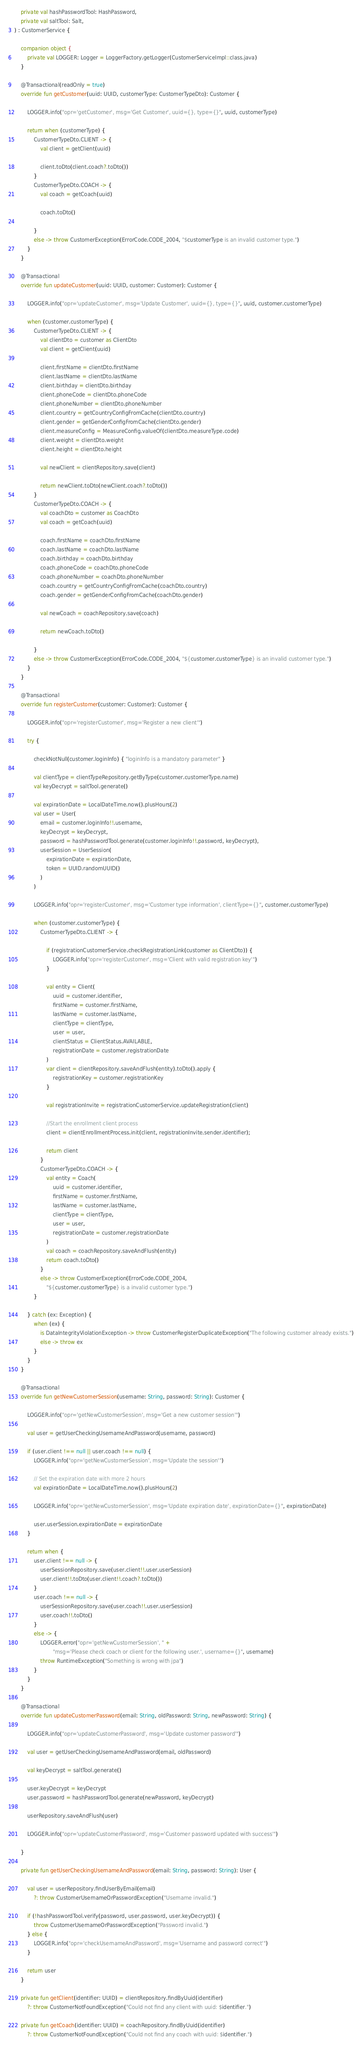Convert code to text. <code><loc_0><loc_0><loc_500><loc_500><_Kotlin_>    private val hashPasswordTool: HashPassword,
    private val saltTool: Salt,
) : CustomerService {

    companion object {
        private val LOGGER: Logger = LoggerFactory.getLogger(CustomerServiceImpl::class.java)
    }

    @Transactional(readOnly = true)
    override fun getCustomer(uuid: UUID, customerType: CustomerTypeDto): Customer {

        LOGGER.info("opr='getCustomer', msg='Get Customer', uuid={}, type={}", uuid, customerType)

        return when (customerType) {
            CustomerTypeDto.CLIENT -> {
                val client = getClient(uuid)

                client.toDto(client.coach?.toDto())
            }
            CustomerTypeDto.COACH -> {
                val coach = getCoach(uuid)

                coach.toDto()

            }
            else -> throw CustomerException(ErrorCode.CODE_2004, "$customerType is an invalid customer type.")
        }
    }

    @Transactional
    override fun updateCustomer(uuid: UUID, customer: Customer): Customer {

        LOGGER.info("opr='updateCustomer', msg='Update Customer', uuid={}, type={}", uuid, customer.customerType)

        when (customer.customerType) {
            CustomerTypeDto.CLIENT -> {
                val clientDto = customer as ClientDto
                val client = getClient(uuid)

                client.firstName = clientDto.firstName
                client.lastName = clientDto.lastName
                client.birthday = clientDto.birthday
                client.phoneCode = clientDto.phoneCode
                client.phoneNumber = clientDto.phoneNumber
                client.country = getCountryConfigFromCache(clientDto.country)
                client.gender = getGenderConfigFromCache(clientDto.gender)
                client.measureConfig = MeasureConfig.valueOf(clientDto.measureType.code)
                client.weight = clientDto.weight
                client.height = clientDto.height

                val newClient = clientRepository.save(client)

                return newClient.toDto(newClient.coach?.toDto())
            }
            CustomerTypeDto.COACH -> {
                val coachDto = customer as CoachDto
                val coach = getCoach(uuid)

                coach.firstName = coachDto.firstName
                coach.lastName = coachDto.lastName
                coach.birthday = coachDto.birthday
                coach.phoneCode = coachDto.phoneCode
                coach.phoneNumber = coachDto.phoneNumber
                coach.country = getCountryConfigFromCache(coachDto.country)
                coach.gender = getGenderConfigFromCache(coachDto.gender)

                val newCoach = coachRepository.save(coach)

                return newCoach.toDto()

            }
            else -> throw CustomerException(ErrorCode.CODE_2004, "${customer.customerType} is an invalid customer type.")
        }
    }

    @Transactional
    override fun registerCustomer(customer: Customer): Customer {

        LOGGER.info("opr='registerCustomer', msg='Register a new client'")

        try {

            checkNotNull(customer.loginInfo) { "loginInfo is a mandatory parameter" }

            val clientType = clientTypeRepository.getByType(customer.customerType.name)
            val keyDecrypt = saltTool.generate()

            val expirationDate = LocalDateTime.now().plusHours(2)
            val user = User(
                email = customer.loginInfo!!.username,
                keyDecrypt = keyDecrypt,
                password = hashPasswordTool.generate(customer.loginInfo!!.password, keyDecrypt),
                userSession = UserSession(
                    expirationDate = expirationDate,
                    token = UUID.randomUUID()
                )
            )

            LOGGER.info("opr='registerCustomer', msg='Customer type information', clientType={}", customer.customerType)

            when (customer.customerType) {
                CustomerTypeDto.CLIENT -> {

                    if (registrationCustomerService.checkRegistrationLink(customer as ClientDto)) {
                        LOGGER.info("opr='registerCustomer', msg='Client with valid registration key'")
                    }

                    val entity = Client(
                        uuid = customer.identifier,
                        firstName = customer.firstName,
                        lastName = customer.lastName,
                        clientType = clientType,
                        user = user,
                        clientStatus = ClientStatus.AVAILABLE,
                        registrationDate = customer.registrationDate
                    )
                    var client = clientRepository.saveAndFlush(entity).toDto().apply {
                        registrationKey = customer.registrationKey
                    }

                    val registrationInvite = registrationCustomerService.updateRegistration(client)

                    //Start the enrollment client process
                    client = clientEnrollmentProcess.init(client, registrationInvite.sender.identifier);

                    return client
                }
                CustomerTypeDto.COACH -> {
                    val entity = Coach(
                        uuid = customer.identifier,
                        firstName = customer.firstName,
                        lastName = customer.lastName,
                        clientType = clientType,
                        user = user,
                        registrationDate = customer.registrationDate
                    )
                    val coach = coachRepository.saveAndFlush(entity)
                    return coach.toDto()
                }
                else -> throw CustomerException(ErrorCode.CODE_2004,
                    "${customer.customerType} is a invalid customer type.")
            }

        } catch (ex: Exception) {
            when (ex) {
                is DataIntegrityViolationException -> throw CustomerRegisterDuplicateException("The following customer already exists.")
                else -> throw ex
            }
        }
    }

    @Transactional
    override fun getNewCustomerSession(username: String, password: String): Customer {

        LOGGER.info("opr='getNewCustomerSession', msg='Get a new customer session'")

        val user = getUserCheckingUsernameAndPassword(username, password)

        if (user.client !== null || user.coach !== null) {
            LOGGER.info("opr='getNewCustomerSession', msg='Update the session'")

            // Set the expiration date with more 2 hours
            val expirationDate = LocalDateTime.now().plusHours(2)

            LOGGER.info("opr='getNewCustomerSession', msg='Update expiration date', expirationDate={}", expirationDate)

            user.userSession.expirationDate = expirationDate
        }

        return when {
            user.client !== null -> {
                userSessionRepository.save(user.client!!.user.userSession)
                user.client!!.toDto(user.client!!.coach?.toDto())
            }
            user.coach !== null -> {
                userSessionRepository.save(user.coach!!.user.userSession)
                user.coach!!.toDto()
            }
            else -> {
                LOGGER.error("opr='getNewCustomerSession', " +
                        "msg='Please check coach or client for the following user.', username={}", username)
                throw RuntimeException("Something is wrong with jpa")
            }
        }
    }

    @Transactional
    override fun updateCustomerPassword(email: String, oldPassword: String, newPassword: String) {

        LOGGER.info("opr='updateCustomerPassword', msg='Update customer password'")

        val user = getUserCheckingUsernameAndPassword(email, oldPassword)

        val keyDecrypt = saltTool.generate()

        user.keyDecrypt = keyDecrypt
        user.password = hashPasswordTool.generate(newPassword, keyDecrypt)

        userRepository.saveAndFlush(user)

        LOGGER.info("opr='updateCustomerPassword', msg='Customer password updated with success'")

    }

    private fun getUserCheckingUsernameAndPassword(email: String, password: String): User {

        val user = userRepository.findUserByEmail(email)
            ?: throw CustomerUsernameOrPasswordException("Username invalid.")

        if (!hashPasswordTool.verify(password, user.password, user.keyDecrypt)) {
            throw CustomerUsernameOrPasswordException("Password invalid.")
        } else {
            LOGGER.info("opr='checkUsernameAndPassword', msg='Username and password correct'")
        }

        return user
    }

    private fun getClient(identifier: UUID) = clientRepository.findByUuid(identifier)
        ?: throw CustomerNotFoundException("Could not find any client with uuid: $identifier.")

    private fun getCoach(identifier: UUID) = coachRepository.findByUuid(identifier)
        ?: throw CustomerNotFoundException("Could not find any coach with uuid: $identifier.")
</code> 